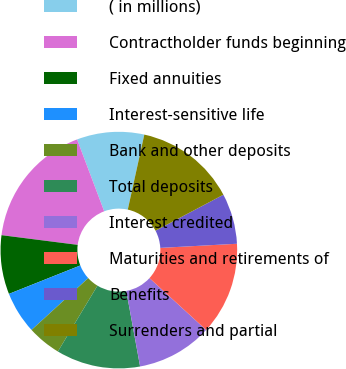Convert chart to OTSL. <chart><loc_0><loc_0><loc_500><loc_500><pie_chart><fcel>( in millions)<fcel>Contractholder funds beginning<fcel>Fixed annuities<fcel>Interest-sensitive life<fcel>Bank and other deposits<fcel>Total deposits<fcel>Interest credited<fcel>Maturities and retirements of<fcel>Benefits<fcel>Surrenders and partial<nl><fcel>9.2%<fcel>17.24%<fcel>8.05%<fcel>5.75%<fcel>4.6%<fcel>11.49%<fcel>10.34%<fcel>12.64%<fcel>6.9%<fcel>13.79%<nl></chart> 